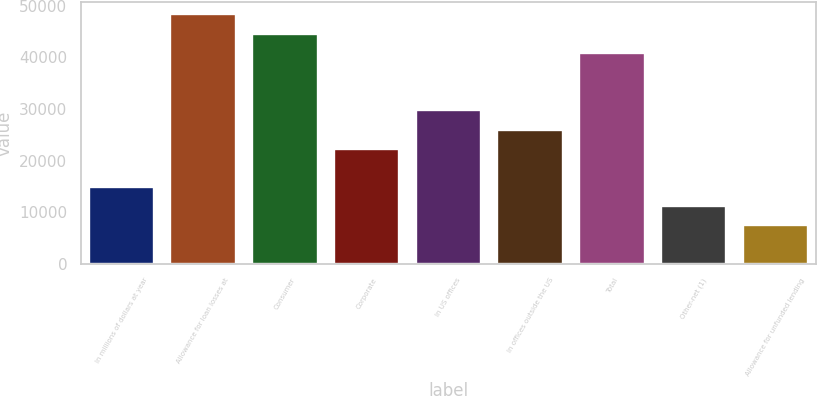Convert chart to OTSL. <chart><loc_0><loc_0><loc_500><loc_500><bar_chart><fcel>In millions of dollars at year<fcel>Allowance for loan losses at<fcel>Consumer<fcel>Corporate<fcel>In US offices<fcel>In offices outside the US<fcel>Total<fcel>Other-net (1)<fcel>Allowance for unfunded lending<nl><fcel>14877.9<fcel>48346.1<fcel>44627.4<fcel>22315.3<fcel>29752.6<fcel>26034<fcel>40908.7<fcel>11159.2<fcel>7440.5<nl></chart> 